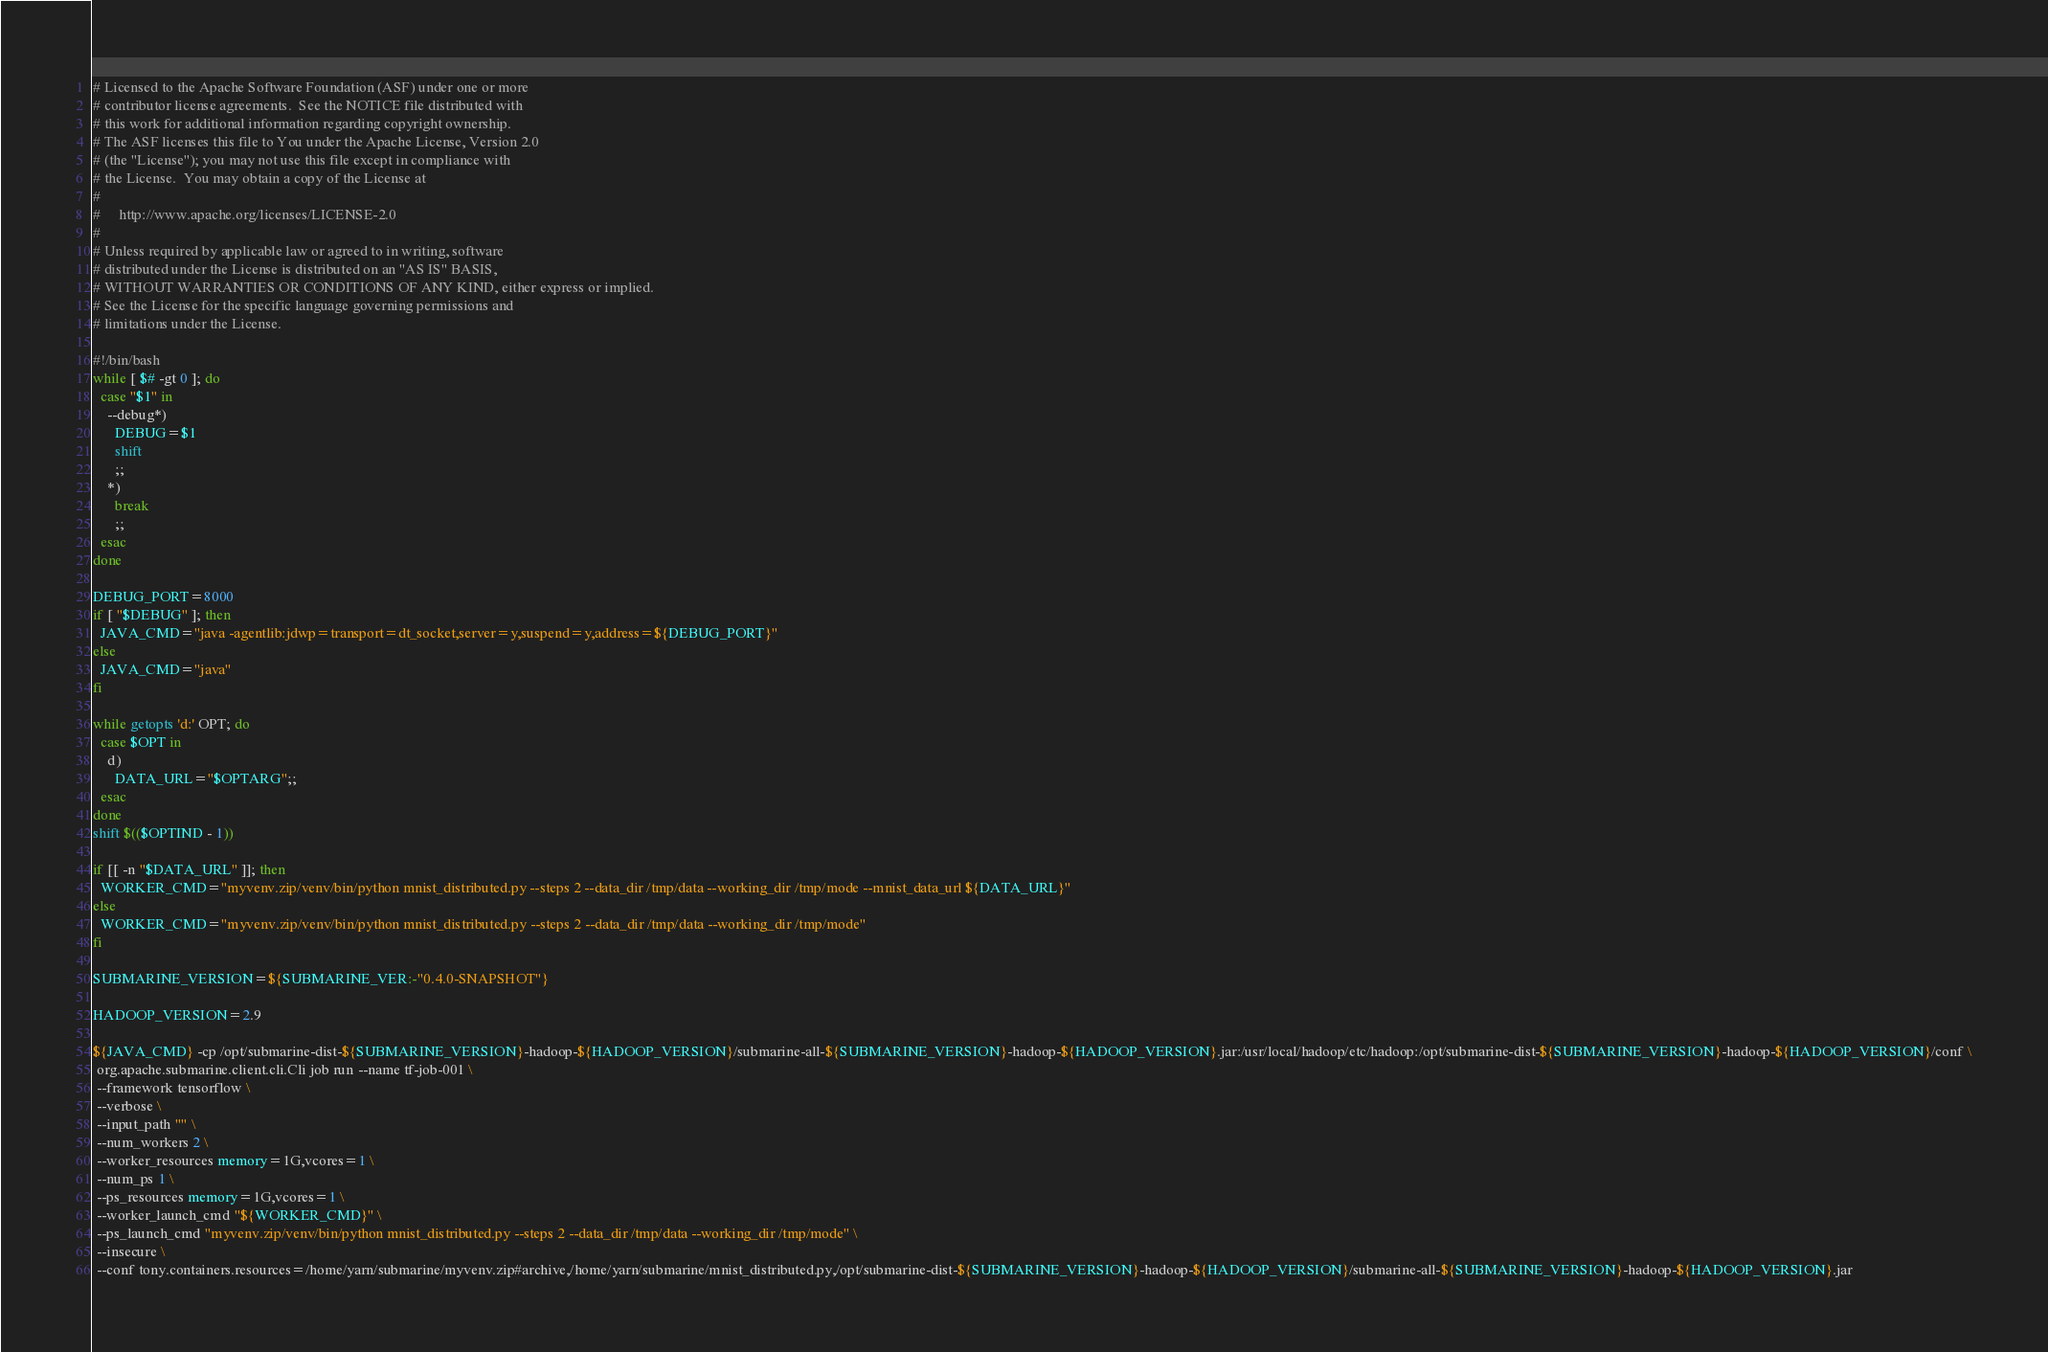<code> <loc_0><loc_0><loc_500><loc_500><_Bash_># Licensed to the Apache Software Foundation (ASF) under one or more
# contributor license agreements.  See the NOTICE file distributed with
# this work for additional information regarding copyright ownership.
# The ASF licenses this file to You under the Apache License, Version 2.0
# (the "License"); you may not use this file except in compliance with
# the License.  You may obtain a copy of the License at
#
#     http://www.apache.org/licenses/LICENSE-2.0
#
# Unless required by applicable law or agreed to in writing, software
# distributed under the License is distributed on an "AS IS" BASIS,
# WITHOUT WARRANTIES OR CONDITIONS OF ANY KIND, either express or implied.
# See the License for the specific language governing permissions and
# limitations under the License.

#!/bin/bash
while [ $# -gt 0 ]; do
  case "$1" in
    --debug*)
      DEBUG=$1
      shift
      ;;
    *)
      break
      ;;
  esac
done

DEBUG_PORT=8000
if [ "$DEBUG" ]; then
  JAVA_CMD="java -agentlib:jdwp=transport=dt_socket,server=y,suspend=y,address=${DEBUG_PORT}"
else
  JAVA_CMD="java"
fi

while getopts 'd:' OPT; do
  case $OPT in
    d)
      DATA_URL="$OPTARG";;
  esac
done
shift $(($OPTIND - 1))

if [[ -n "$DATA_URL" ]]; then
  WORKER_CMD="myvenv.zip/venv/bin/python mnist_distributed.py --steps 2 --data_dir /tmp/data --working_dir /tmp/mode --mnist_data_url ${DATA_URL}"
else
  WORKER_CMD="myvenv.zip/venv/bin/python mnist_distributed.py --steps 2 --data_dir /tmp/data --working_dir /tmp/mode"
fi 

SUBMARINE_VERSION=${SUBMARINE_VER:-"0.4.0-SNAPSHOT"}

HADOOP_VERSION=2.9

${JAVA_CMD} -cp /opt/submarine-dist-${SUBMARINE_VERSION}-hadoop-${HADOOP_VERSION}/submarine-all-${SUBMARINE_VERSION}-hadoop-${HADOOP_VERSION}.jar:/usr/local/hadoop/etc/hadoop:/opt/submarine-dist-${SUBMARINE_VERSION}-hadoop-${HADOOP_VERSION}/conf \
 org.apache.submarine.client.cli.Cli job run --name tf-job-001 \
 --framework tensorflow \
 --verbose \
 --input_path "" \
 --num_workers 2 \
 --worker_resources memory=1G,vcores=1 \
 --num_ps 1 \
 --ps_resources memory=1G,vcores=1 \
 --worker_launch_cmd "${WORKER_CMD}" \
 --ps_launch_cmd "myvenv.zip/venv/bin/python mnist_distributed.py --steps 2 --data_dir /tmp/data --working_dir /tmp/mode" \
 --insecure \
 --conf tony.containers.resources=/home/yarn/submarine/myvenv.zip#archive,/home/yarn/submarine/mnist_distributed.py,/opt/submarine-dist-${SUBMARINE_VERSION}-hadoop-${HADOOP_VERSION}/submarine-all-${SUBMARINE_VERSION}-hadoop-${HADOOP_VERSION}.jar
</code> 